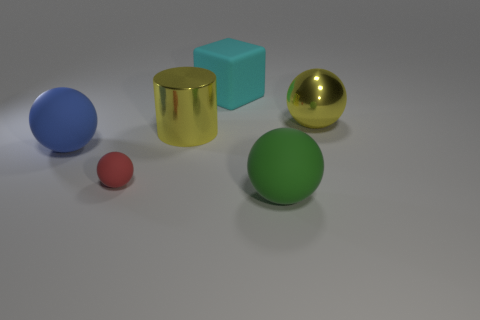Add 1 big blue objects. How many objects exist? 7 Subtract all cylinders. How many objects are left? 5 Add 6 cyan rubber objects. How many cyan rubber objects exist? 7 Subtract 0 brown balls. How many objects are left? 6 Subtract all big blue things. Subtract all tiny rubber cubes. How many objects are left? 5 Add 6 big metal cylinders. How many big metal cylinders are left? 7 